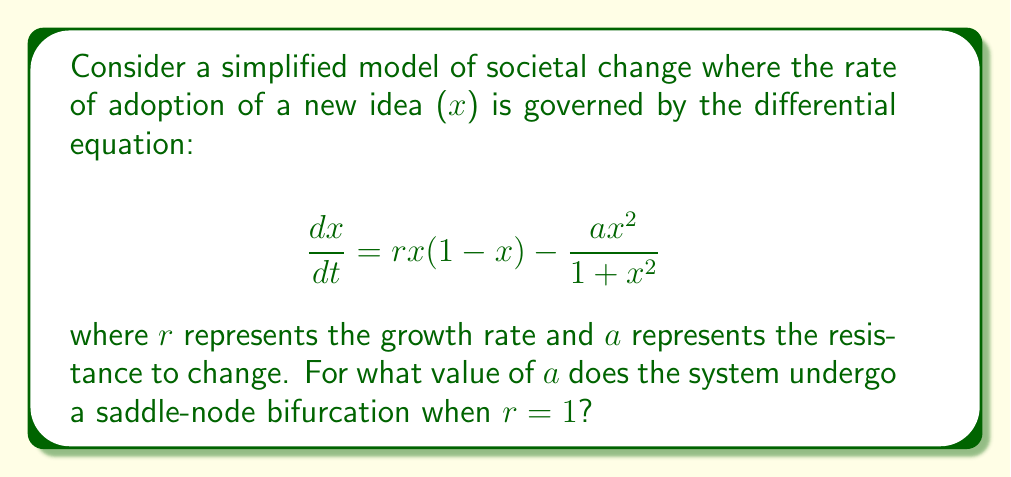Give your solution to this math problem. To find the saddle-node bifurcation point, we need to follow these steps:

1) First, find the equilibrium points by setting $\frac{dx}{dt} = 0$:

   $$rx(1-x) - \frac{ax^2}{1+x^2} = 0$$

2) Rearrange the equation:

   $$rx - rx^2 = \frac{ax^2}{1+x^2}$$

3) Multiply both sides by $(1+x^2)$:

   $$rx(1+x^2) - rx^2(1+x^2) = ax^2$$

4) Expand:

   $$rx + rx^3 - rx^2 - rx^4 = ax^2$$

5) Rearrange to standard form:

   $$rx^4 + (a-r)x^2 - rx = 0$$

6) For a saddle-node bifurcation, this equation should have a double root. This occurs when the discriminant of the quadratic in $x^2$ is zero. Let $y = x^2$:

   $$ry^2 + (a-r)y - rx = 0$$

7) The discriminant of a quadratic $Ay^2 + By + C = 0$ is $B^2 - 4AC$. Here:

   $$B^2 - 4AC = (a-r)^2 - 4r(-rx) = (a-r)^2 + 4r^2x$$

8) Set this equal to zero and substitute $r=1$:

   $$(a-1)^2 + 4x = 0$$

9) For this to be true for some real $x$, we must have:

   $$a-1 = 0$$

10) Therefore:

    $$a = 1$$

This is the value of $a$ at which the saddle-node bifurcation occurs when $r=1$.
Answer: $a = 1$ 